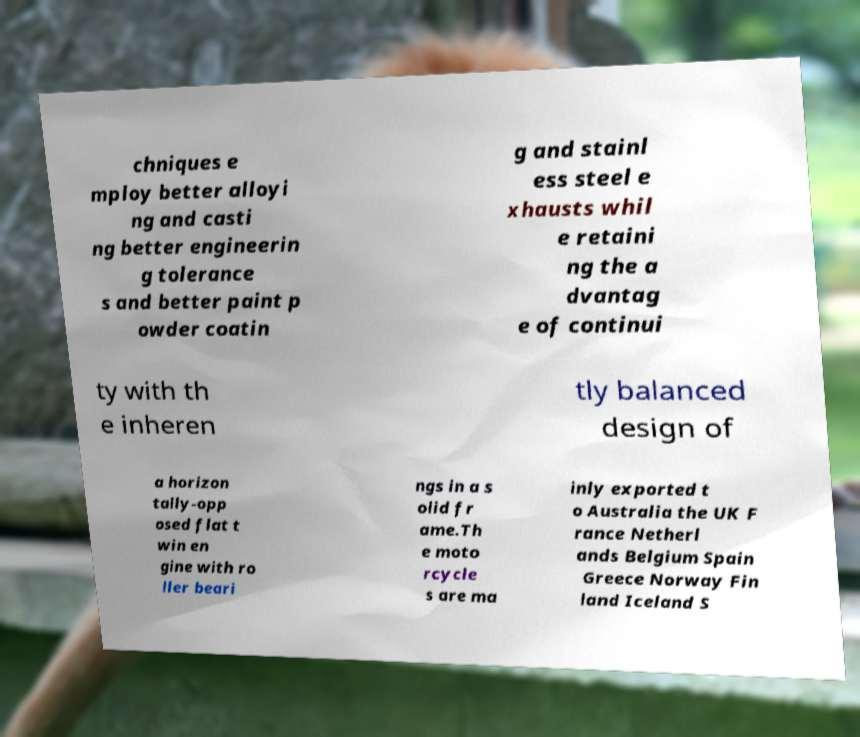For documentation purposes, I need the text within this image transcribed. Could you provide that? chniques e mploy better alloyi ng and casti ng better engineerin g tolerance s and better paint p owder coatin g and stainl ess steel e xhausts whil e retaini ng the a dvantag e of continui ty with th e inheren tly balanced design of a horizon tally-opp osed flat t win en gine with ro ller beari ngs in a s olid fr ame.Th e moto rcycle s are ma inly exported t o Australia the UK F rance Netherl ands Belgium Spain Greece Norway Fin land Iceland S 